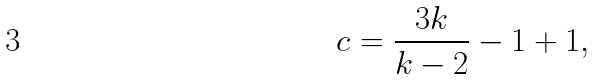Convert formula to latex. <formula><loc_0><loc_0><loc_500><loc_500>c = \frac { 3 k } { k - 2 } - 1 + 1 ,</formula> 